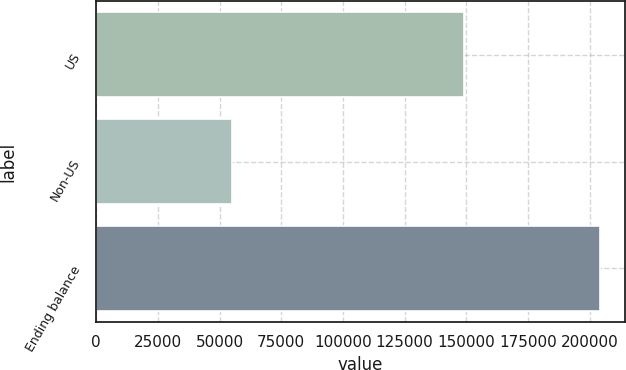Convert chart to OTSL. <chart><loc_0><loc_0><loc_500><loc_500><bar_chart><fcel>US<fcel>Non-US<fcel>Ending balance<nl><fcel>149085<fcel>55090<fcel>204175<nl></chart> 